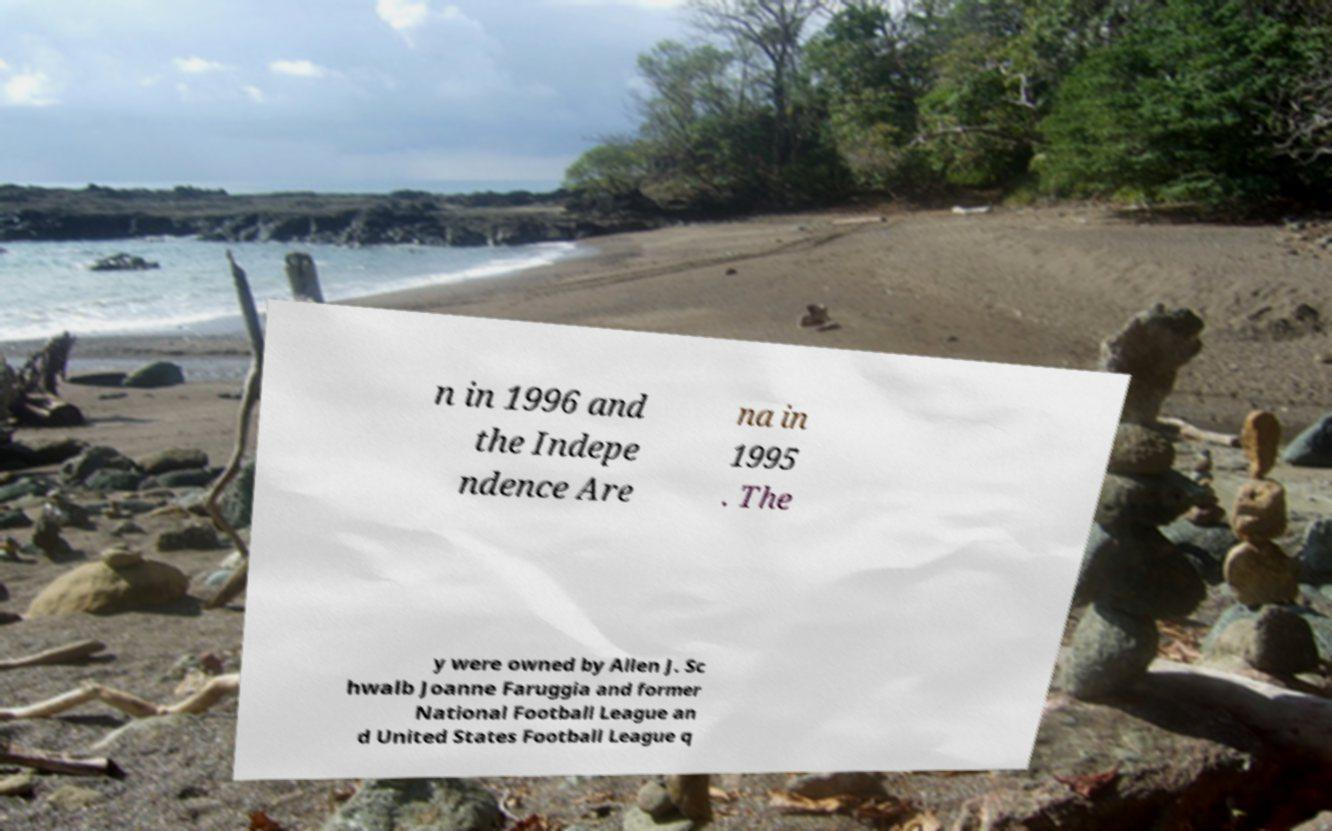Please read and relay the text visible in this image. What does it say? n in 1996 and the Indepe ndence Are na in 1995 . The y were owned by Allen J. Sc hwalb Joanne Faruggia and former National Football League an d United States Football League q 